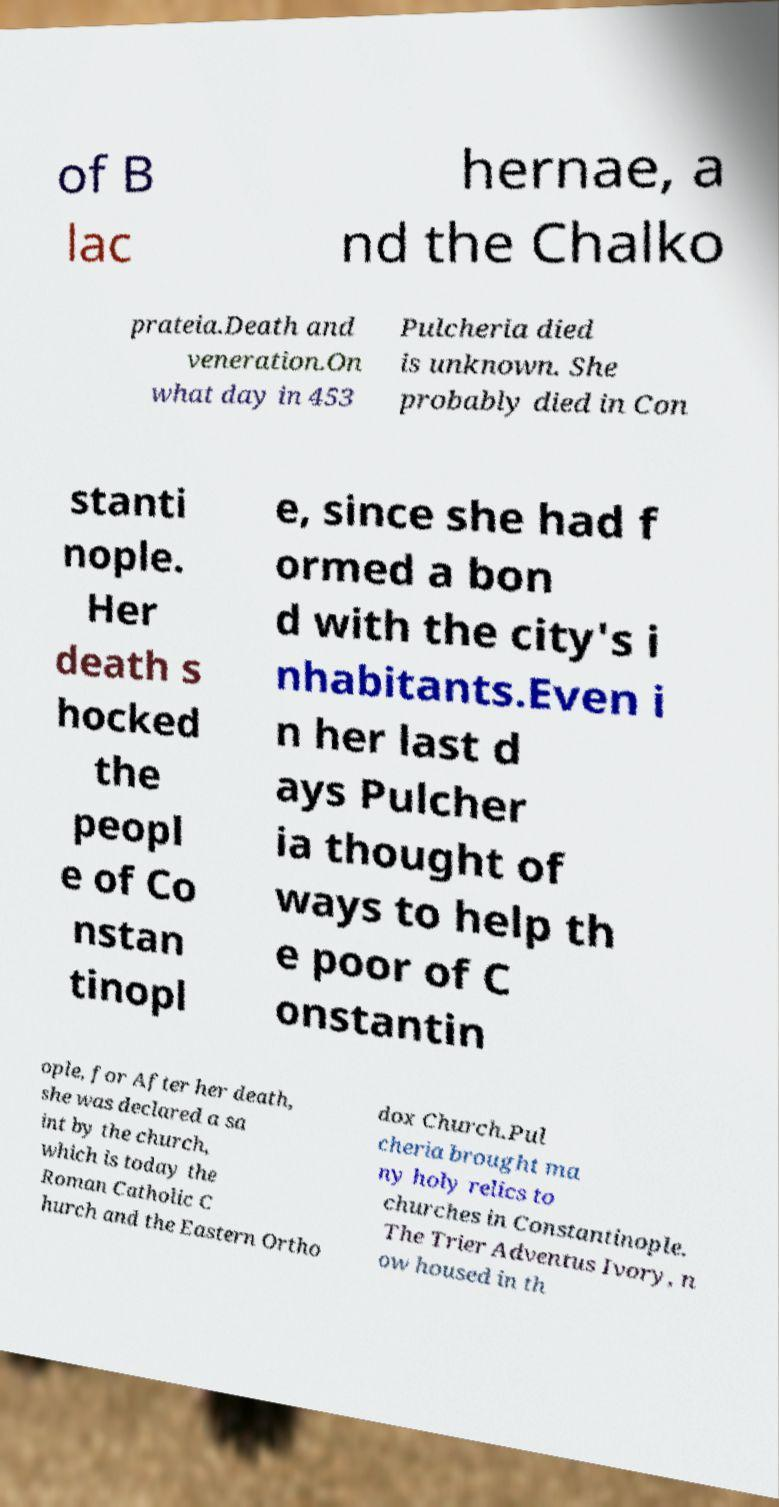Please read and relay the text visible in this image. What does it say? of B lac hernae, a nd the Chalko prateia.Death and veneration.On what day in 453 Pulcheria died is unknown. She probably died in Con stanti nople. Her death s hocked the peopl e of Co nstan tinopl e, since she had f ormed a bon d with the city's i nhabitants.Even i n her last d ays Pulcher ia thought of ways to help th e poor of C onstantin ople, for After her death, she was declared a sa int by the church, which is today the Roman Catholic C hurch and the Eastern Ortho dox Church.Pul cheria brought ma ny holy relics to churches in Constantinople. The Trier Adventus Ivory, n ow housed in th 